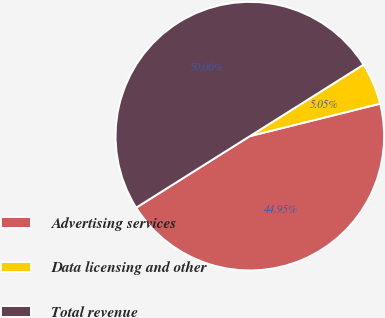Convert chart to OTSL. <chart><loc_0><loc_0><loc_500><loc_500><pie_chart><fcel>Advertising services<fcel>Data licensing and other<fcel>Total revenue<nl><fcel>44.95%<fcel>5.05%<fcel>50.0%<nl></chart> 